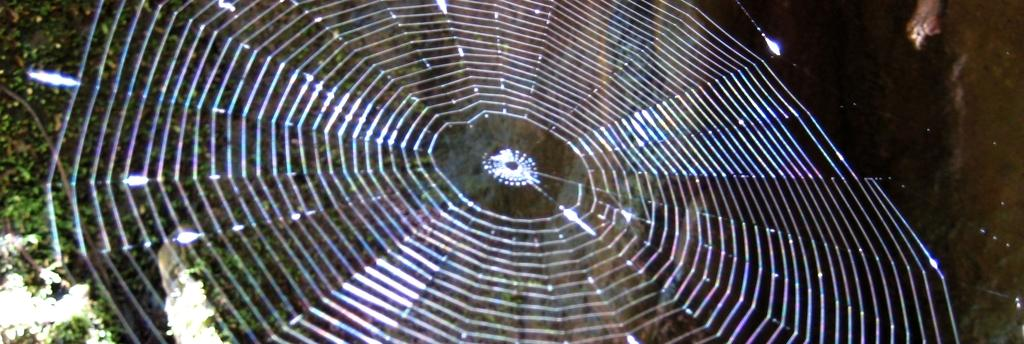What is the main subject of the image? The main subject of the image is a spider web. How would you describe the background of the image? The background of the image is blurry. What type of vegetation can be seen in the background? Green leaves are visible in the background of the image. How many brothers does the spider have in the image? There are no spiders or family members mentioned in the image, so it is impossible to determine the number of brothers the spider might have. 